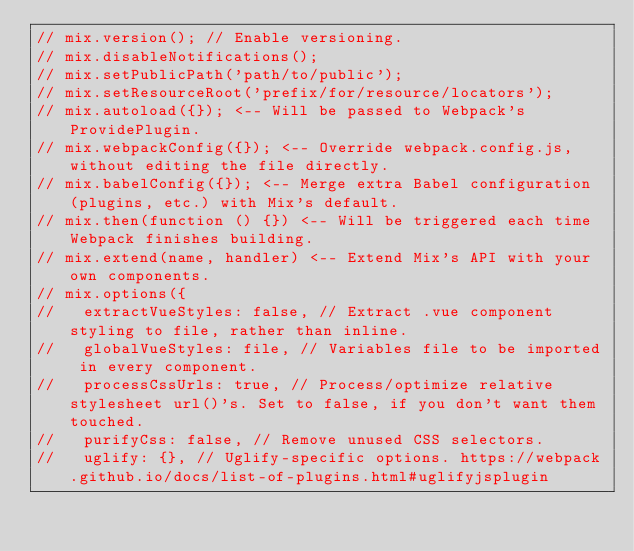Convert code to text. <code><loc_0><loc_0><loc_500><loc_500><_JavaScript_>// mix.version(); // Enable versioning.
// mix.disableNotifications();
// mix.setPublicPath('path/to/public');
// mix.setResourceRoot('prefix/for/resource/locators');
// mix.autoload({}); <-- Will be passed to Webpack's ProvidePlugin.
// mix.webpackConfig({}); <-- Override webpack.config.js, without editing the file directly.
// mix.babelConfig({}); <-- Merge extra Babel configuration (plugins, etc.) with Mix's default.
// mix.then(function () {}) <-- Will be triggered each time Webpack finishes building.
// mix.extend(name, handler) <-- Extend Mix's API with your own components.
// mix.options({
//   extractVueStyles: false, // Extract .vue component styling to file, rather than inline.
//   globalVueStyles: file, // Variables file to be imported in every component.
//   processCssUrls: true, // Process/optimize relative stylesheet url()'s. Set to false, if you don't want them touched.
//   purifyCss: false, // Remove unused CSS selectors.
//   uglify: {}, // Uglify-specific options. https://webpack.github.io/docs/list-of-plugins.html#uglifyjsplugin</code> 